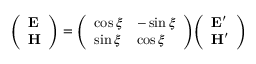Convert formula to latex. <formula><loc_0><loc_0><loc_500><loc_500>{ \left ( \begin{array} { l } { E } \\ { H } \end{array} \right ) } = { \left ( \begin{array} { l l } { \cos \xi } & { - \sin \xi } \\ { \sin \xi } & { \cos \xi } \end{array} \right ) } { \left ( \begin{array} { l } { E ^ { \prime } } \\ { H ^ { \prime } } \end{array} \right ) }</formula> 